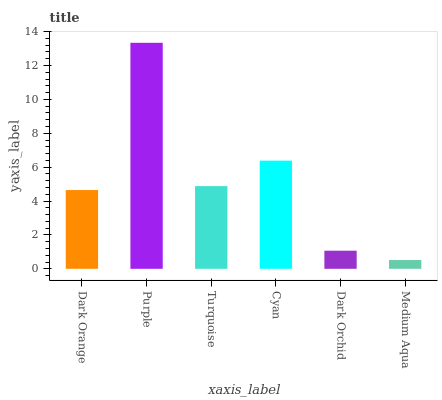Is Medium Aqua the minimum?
Answer yes or no. Yes. Is Purple the maximum?
Answer yes or no. Yes. Is Turquoise the minimum?
Answer yes or no. No. Is Turquoise the maximum?
Answer yes or no. No. Is Purple greater than Turquoise?
Answer yes or no. Yes. Is Turquoise less than Purple?
Answer yes or no. Yes. Is Turquoise greater than Purple?
Answer yes or no. No. Is Purple less than Turquoise?
Answer yes or no. No. Is Turquoise the high median?
Answer yes or no. Yes. Is Dark Orange the low median?
Answer yes or no. Yes. Is Purple the high median?
Answer yes or no. No. Is Turquoise the low median?
Answer yes or no. No. 